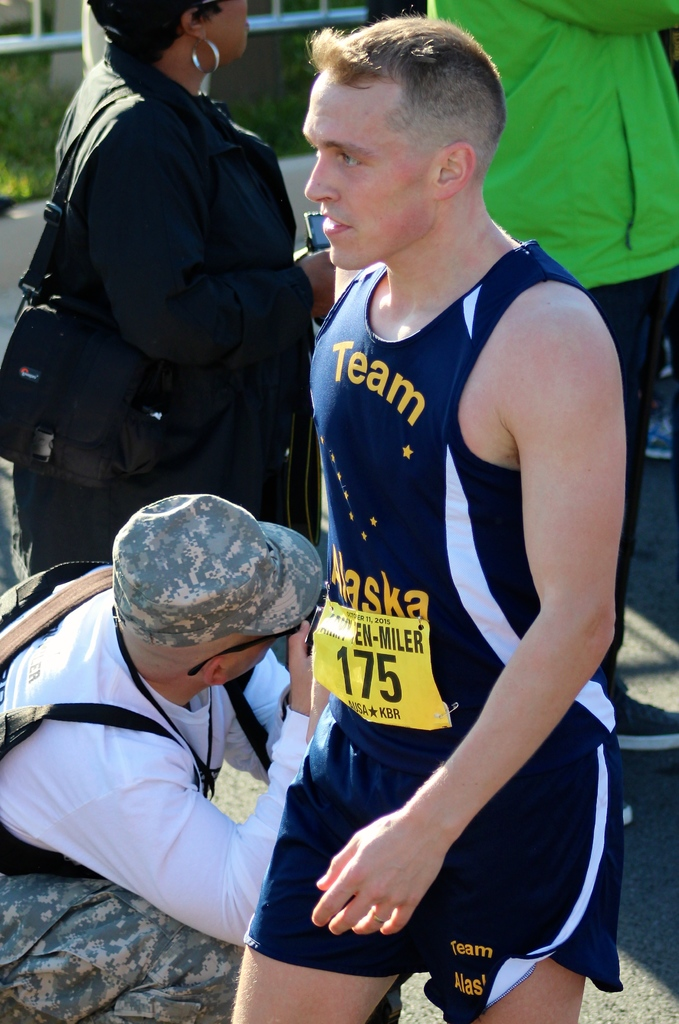Can you explain the significance of the logos and text on the athlete's outfit? The logos and text 'Team Alaska' and 'EN-MILER' indicate that the athlete represents a team from Alaska and is possibly participating in an event named or sponsored by 'EN-MILER'. This suggests a connection to a specific athletic community or sponsorship. What might 'EN-MILER' refer to in this context? While 'EN-MILER' is not a widely recognized event, it could potentially refer to a specialized or local endurance running event, emphasizing mile-long distances or challenges, particularly in or connected to Alaska. 